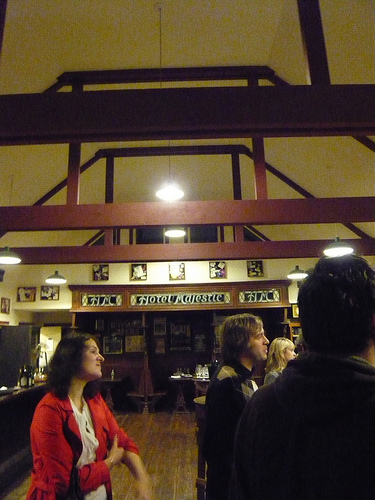<image>
Is there a man next to the woman? Yes. The man is positioned adjacent to the woman, located nearby in the same general area. 